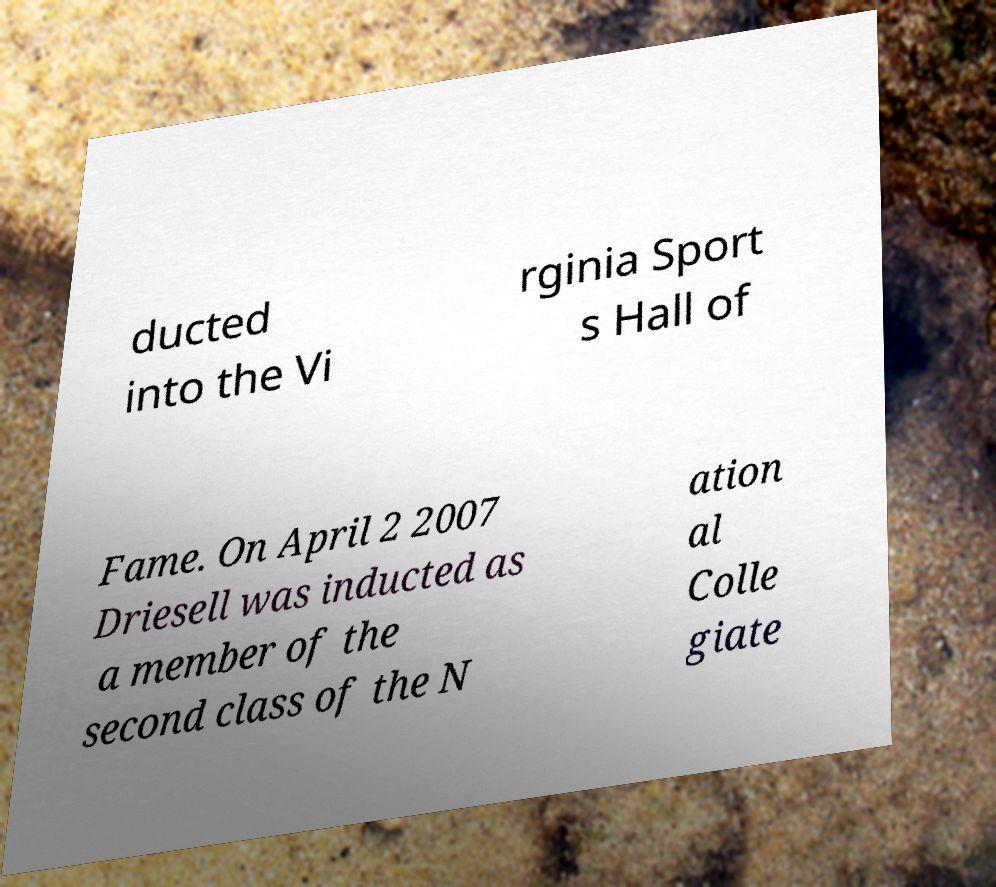Could you assist in decoding the text presented in this image and type it out clearly? ducted into the Vi rginia Sport s Hall of Fame. On April 2 2007 Driesell was inducted as a member of the second class of the N ation al Colle giate 